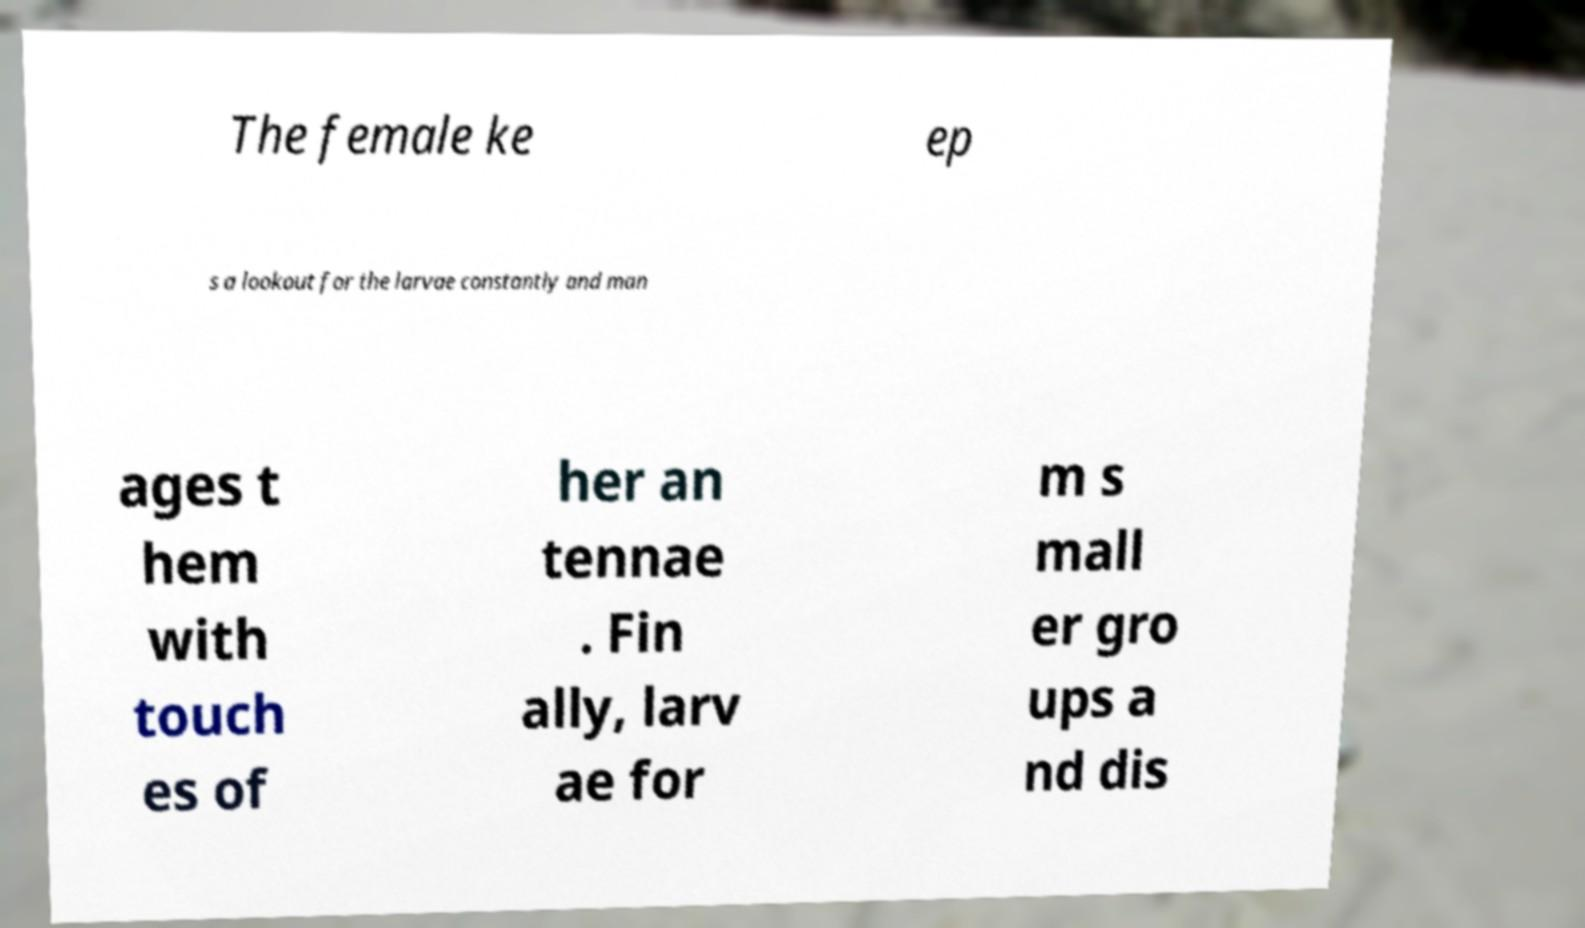Can you accurately transcribe the text from the provided image for me? The female ke ep s a lookout for the larvae constantly and man ages t hem with touch es of her an tennae . Fin ally, larv ae for m s mall er gro ups a nd dis 